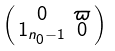Convert formula to latex. <formula><loc_0><loc_0><loc_500><loc_500>\begin{psmallmatrix} 0 & \varpi \\ 1 _ { n _ { 0 } - 1 } & 0 \end{psmallmatrix}</formula> 